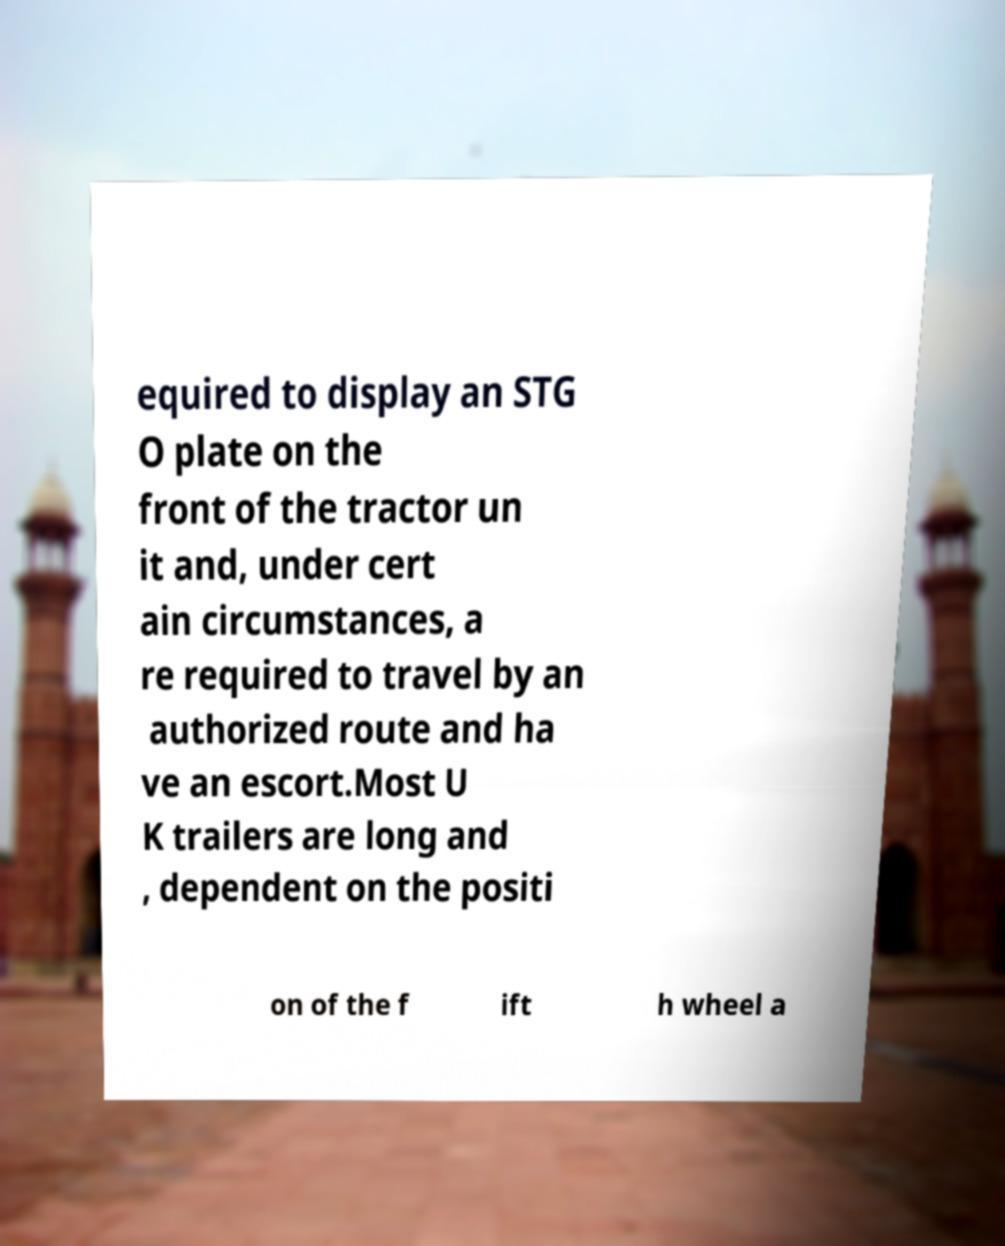Can you accurately transcribe the text from the provided image for me? equired to display an STG O plate on the front of the tractor un it and, under cert ain circumstances, a re required to travel by an authorized route and ha ve an escort.Most U K trailers are long and , dependent on the positi on of the f ift h wheel a 